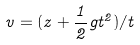Convert formula to latex. <formula><loc_0><loc_0><loc_500><loc_500>v = ( z + \frac { 1 } { 2 } g t ^ { 2 } ) / t</formula> 